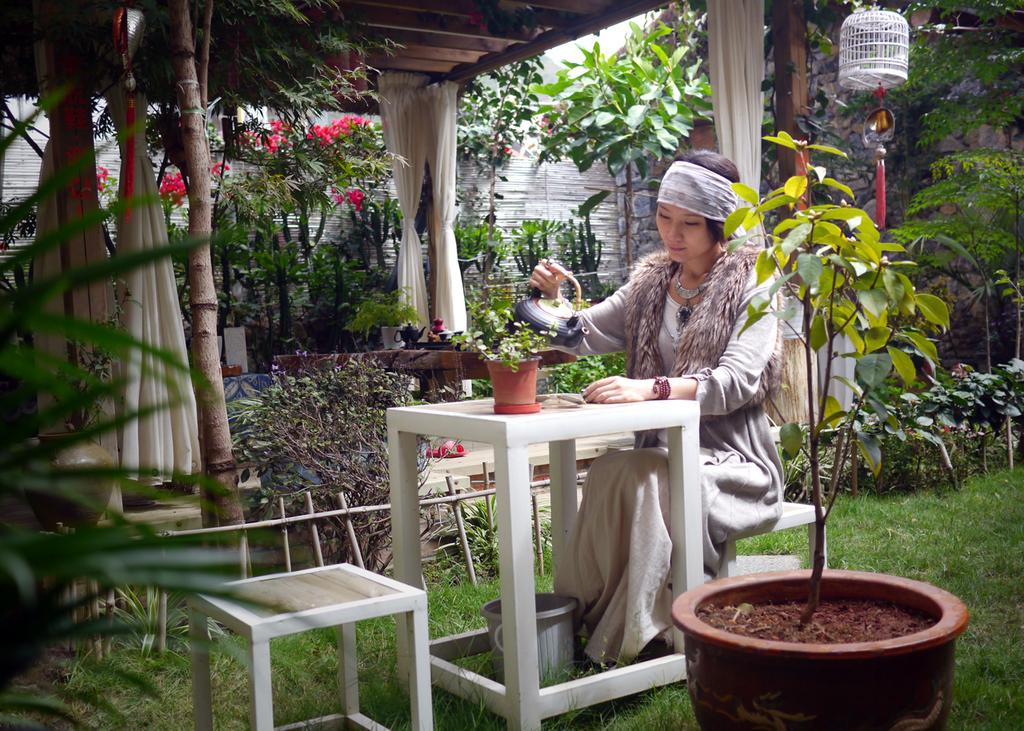Who is the main subject in the image? There is a lady in the image. What is the lady wearing? The lady is wearing a white dress. What is the lady sitting on? The lady is sitting on a stool. What can be seen in front of the stool? There is a garden in front of the stool. What type of flame can be seen in the garden in the image? There is no flame present in the garden or the image. 